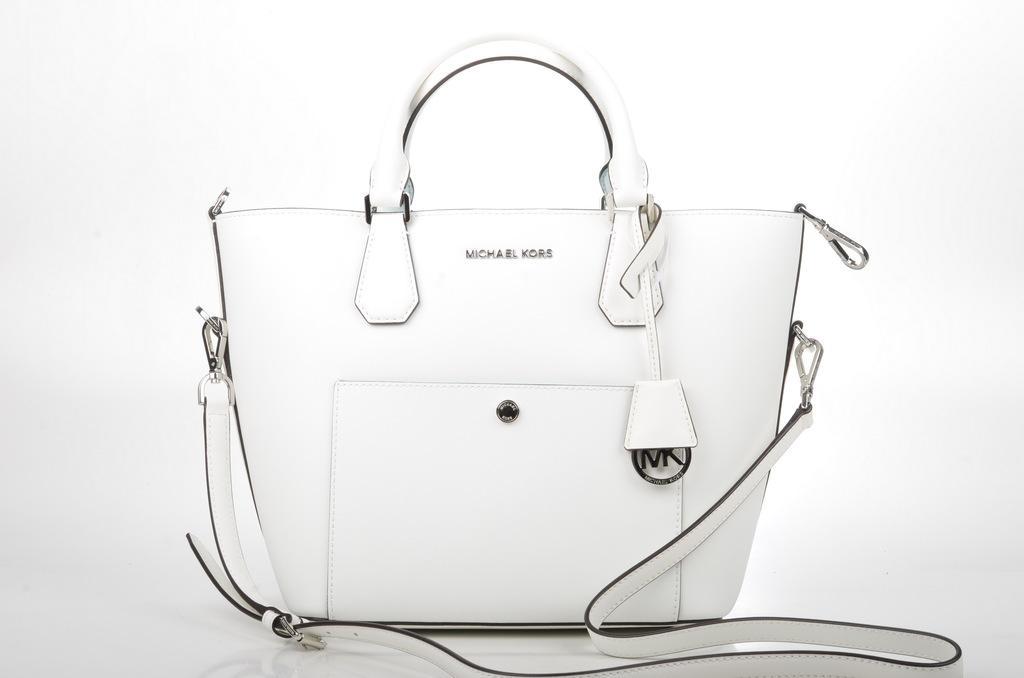How would you summarize this image in a sentence or two? This picture shows a white color handbag placed on the floor. In the background there is a white. 